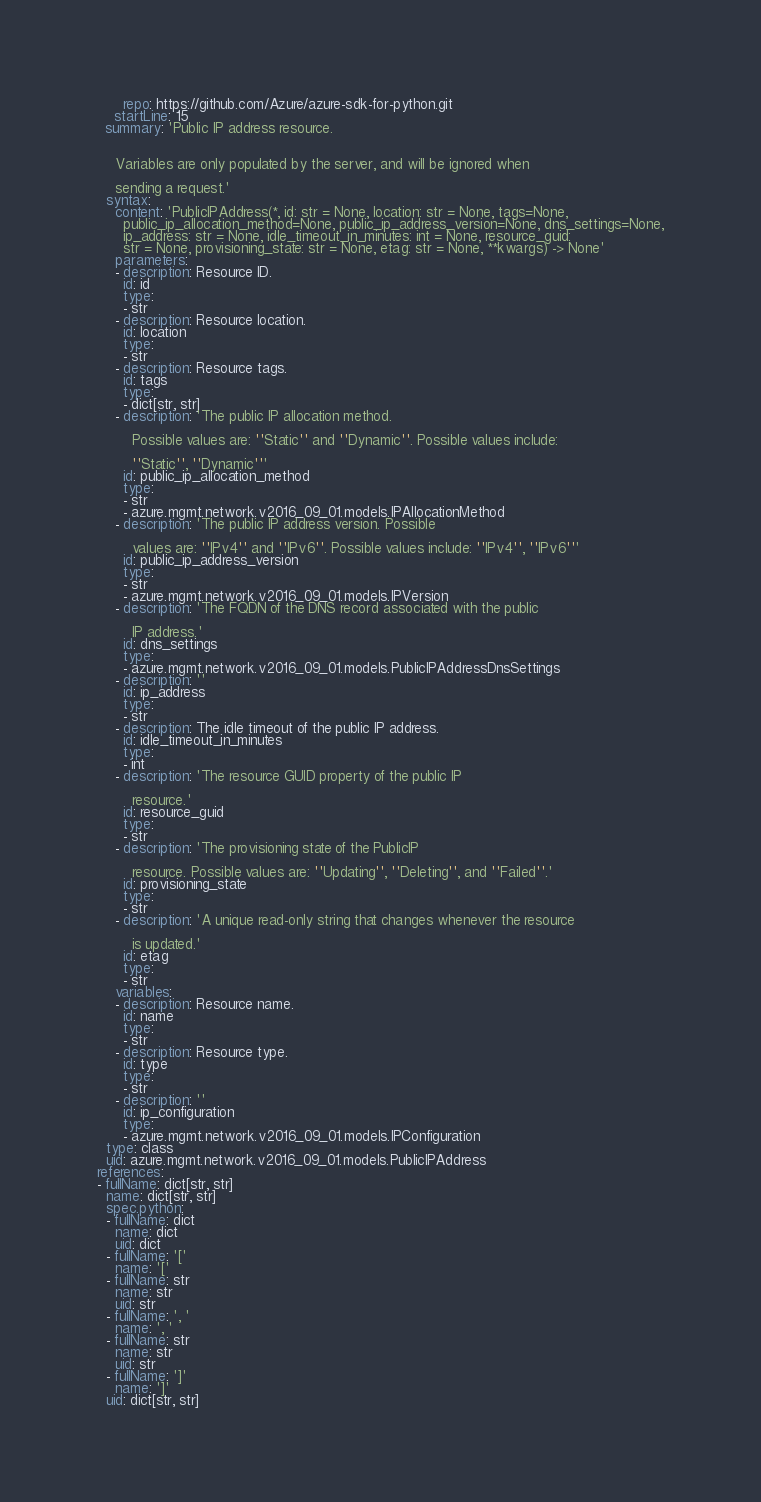<code> <loc_0><loc_0><loc_500><loc_500><_YAML_>      repo: https://github.com/Azure/azure-sdk-for-python.git
    startLine: 15
  summary: 'Public IP address resource.


    Variables are only populated by the server, and will be ignored when

    sending a request.'
  syntax:
    content: 'PublicIPAddress(*, id: str = None, location: str = None, tags=None,
      public_ip_allocation_method=None, public_ip_address_version=None, dns_settings=None,
      ip_address: str = None, idle_timeout_in_minutes: int = None, resource_guid:
      str = None, provisioning_state: str = None, etag: str = None, **kwargs) -> None'
    parameters:
    - description: Resource ID.
      id: id
      type:
      - str
    - description: Resource location.
      id: location
      type:
      - str
    - description: Resource tags.
      id: tags
      type:
      - dict[str, str]
    - description: 'The public IP allocation method.

        Possible values are: ''Static'' and ''Dynamic''. Possible values include:

        ''Static'', ''Dynamic'''
      id: public_ip_allocation_method
      type:
      - str
      - azure.mgmt.network.v2016_09_01.models.IPAllocationMethod
    - description: 'The public IP address version. Possible

        values are: ''IPv4'' and ''IPv6''. Possible values include: ''IPv4'', ''IPv6'''
      id: public_ip_address_version
      type:
      - str
      - azure.mgmt.network.v2016_09_01.models.IPVersion
    - description: 'The FQDN of the DNS record associated with the public

        IP address.'
      id: dns_settings
      type:
      - azure.mgmt.network.v2016_09_01.models.PublicIPAddressDnsSettings
    - description: ''
      id: ip_address
      type:
      - str
    - description: The idle timeout of the public IP address.
      id: idle_timeout_in_minutes
      type:
      - int
    - description: 'The resource GUID property of the public IP

        resource.'
      id: resource_guid
      type:
      - str
    - description: 'The provisioning state of the PublicIP

        resource. Possible values are: ''Updating'', ''Deleting'', and ''Failed''.'
      id: provisioning_state
      type:
      - str
    - description: 'A unique read-only string that changes whenever the resource

        is updated.'
      id: etag
      type:
      - str
    variables:
    - description: Resource name.
      id: name
      type:
      - str
    - description: Resource type.
      id: type
      type:
      - str
    - description: ''
      id: ip_configuration
      type:
      - azure.mgmt.network.v2016_09_01.models.IPConfiguration
  type: class
  uid: azure.mgmt.network.v2016_09_01.models.PublicIPAddress
references:
- fullName: dict[str, str]
  name: dict[str, str]
  spec.python:
  - fullName: dict
    name: dict
    uid: dict
  - fullName: '['
    name: '['
  - fullName: str
    name: str
    uid: str
  - fullName: ', '
    name: ', '
  - fullName: str
    name: str
    uid: str
  - fullName: ']'
    name: ']'
  uid: dict[str, str]
</code> 